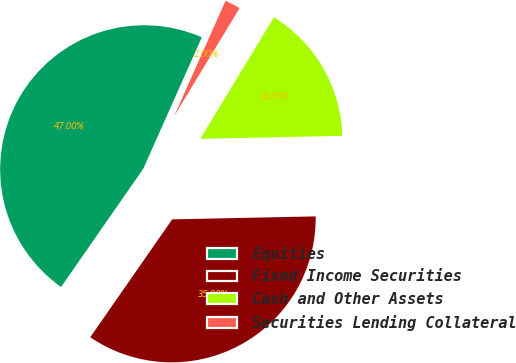Convert chart to OTSL. <chart><loc_0><loc_0><loc_500><loc_500><pie_chart><fcel>Equities<fcel>Fixed Income Securities<fcel>Cash and Other Assets<fcel>Securities Lending Collateral<nl><fcel>47.0%<fcel>35.0%<fcel>16.0%<fcel>2.0%<nl></chart> 